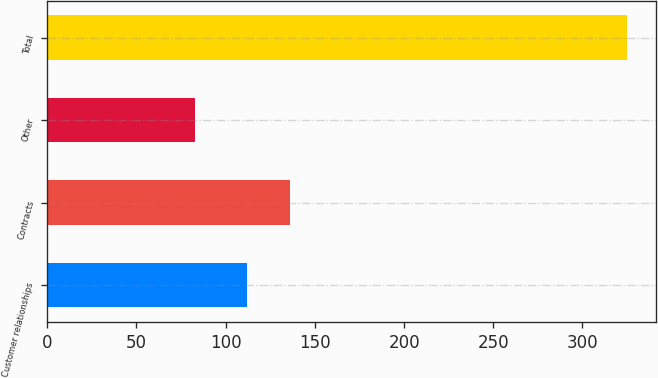Convert chart to OTSL. <chart><loc_0><loc_0><loc_500><loc_500><bar_chart><fcel>Customer relationships<fcel>Contracts<fcel>Other<fcel>Total<nl><fcel>112<fcel>136.2<fcel>83<fcel>325<nl></chart> 